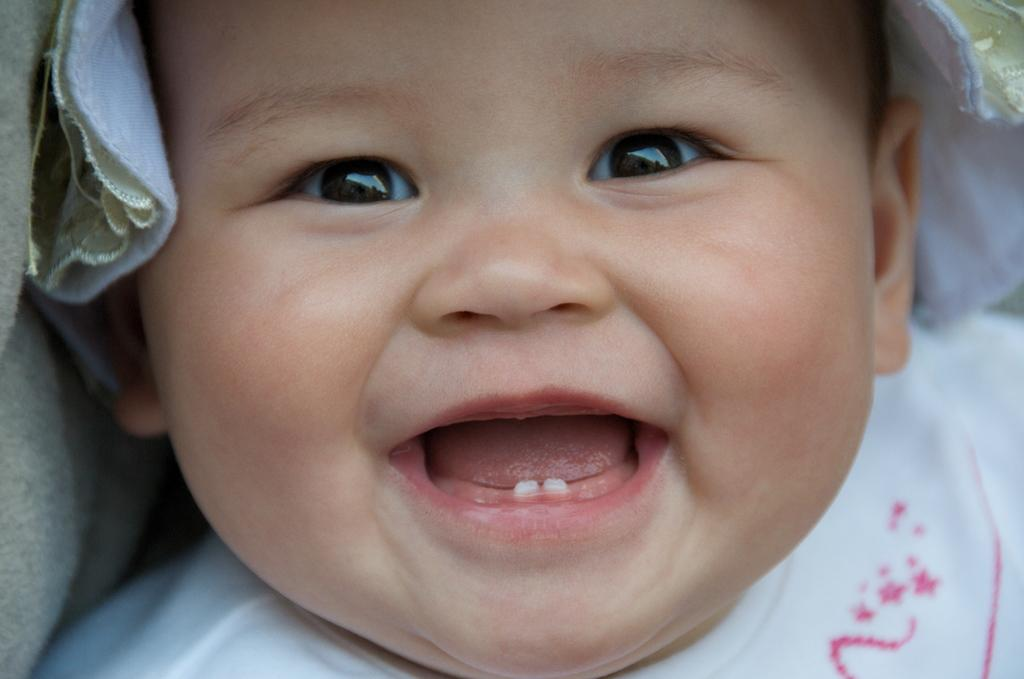What is the expression on the baby's face in the image? The baby is smiling in the image. What type of trousers is the baby wearing in the image? The provided facts do not mention any clothing, including trousers, so we cannot determine what type of trousers the baby is wearing. 